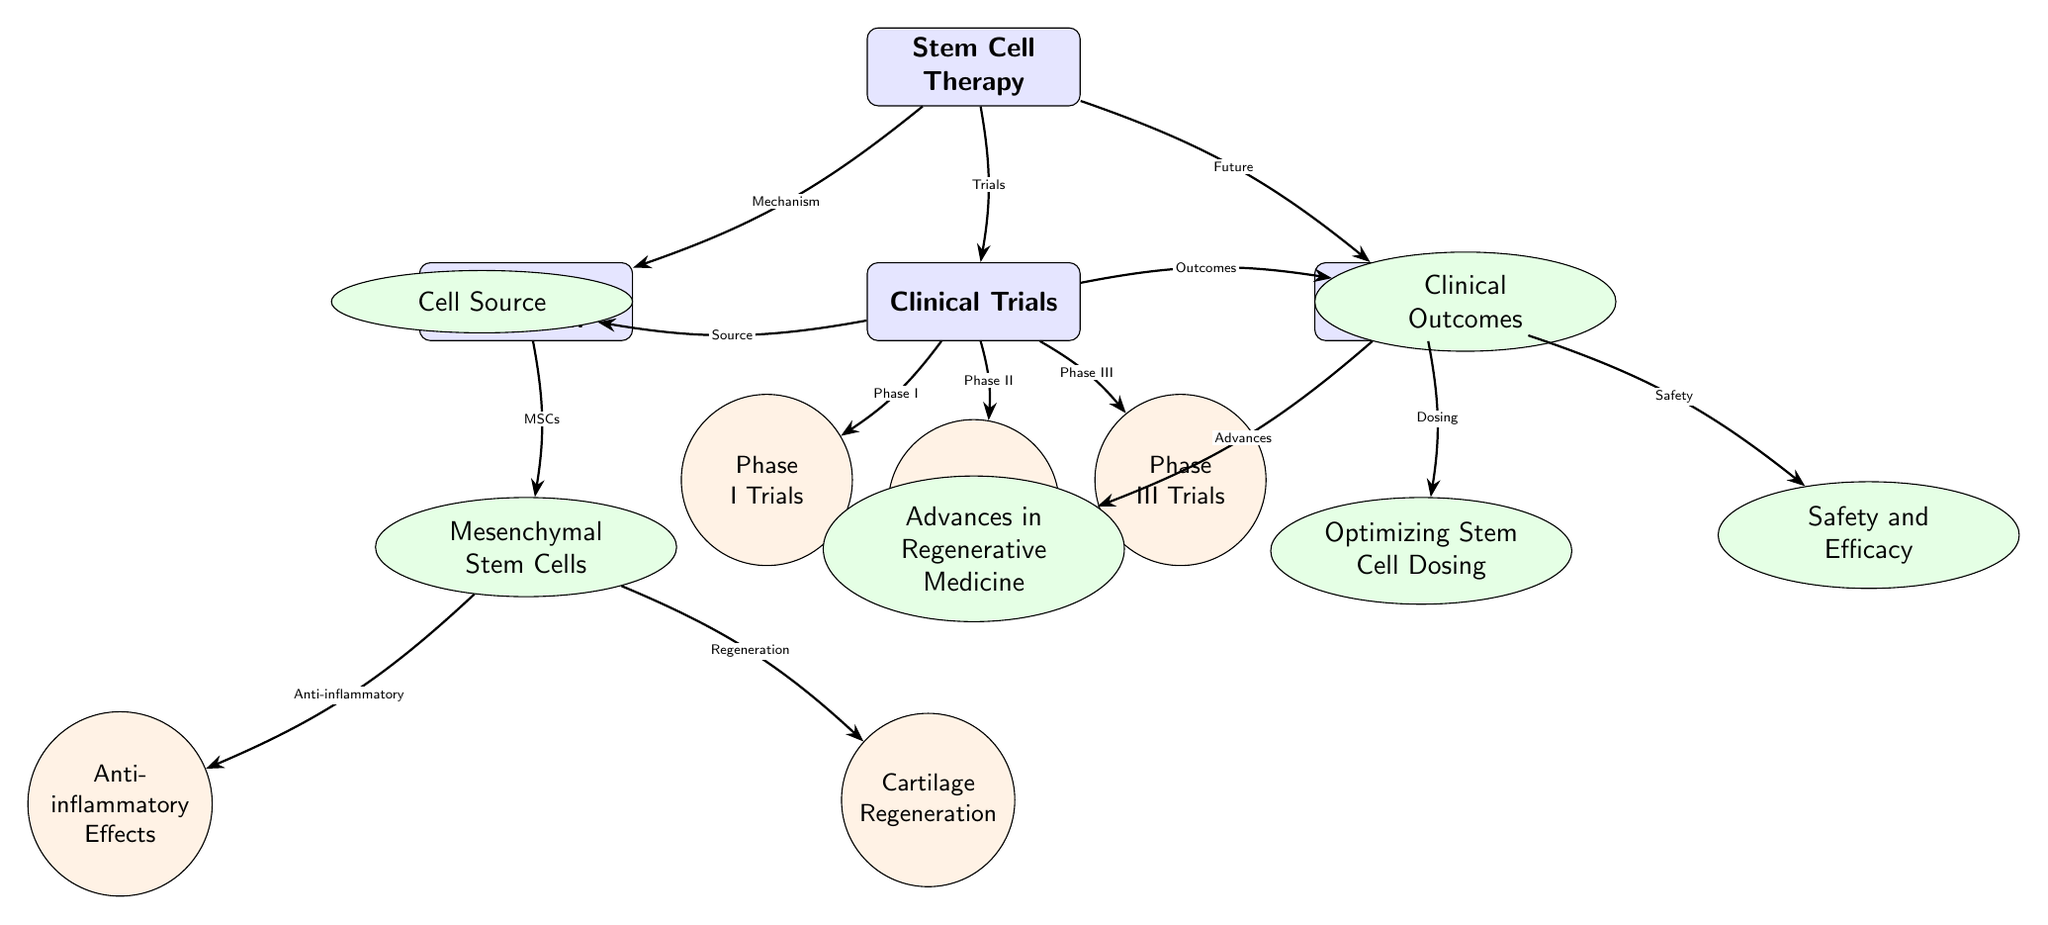What is the main focus of the diagram? The diagram primarily depicts "Stem Cell Therapy" as its central theme. It provides an overview of its mechanism of action, clinical trials, and future prospects related to osteoarthritis treatment.
Answer: Stem Cell Therapy How many main nodes are there in the diagram? There are four main nodes: Stem Cell Therapy, Mechanism of Action, Clinical Trials, and Future Prospects. Counting these nodes leads to the total number.
Answer: Four What type of stem cells is highlighted in the mechanism of action? The diagram specifies "Mesenchymal Stem Cells" as the relevant cell type in the mechanism of action related to stem cell therapy.
Answer: Mesenchymal Stem Cells Which clinical trial phase is directly connected to the "Clinical Outcomes" node? "Clinical Outcomes" has direct connections leading to the clinical trial phases, and the node that is most closely connected is specifically "Phase III Trials."
Answer: Phase III Trials What effect is associated with mesenchymal stem cells in the mechanism of action? According to the diagram, an "Anti-inflammatory" effect is attributed to mesenchymal stem cells, indicating a key role they play in the therapeutic process.
Answer: Anti-inflammatory Effects Which aspect of future prospects relates to safety? In the future prospects section of the diagram, "Safety and Efficacy" is directly connected to stem cell therapy, addressing concerns regarding treatment safety.
Answer: Safety and Efficacy What connects the primary node of stem cell therapy to clinical trials? The connection labeled "Trials" indicates the relationship between stem cell therapy and the clinical trials being conducted for it.
Answer: Trials Which node is positioned below "Cell Source" in clinical trials? "Phase I Trials" is positioned directly below "Cell Source," indicating it is one of the initial stages of clinical trials related to stem cell therapy.
Answer: Phase I Trials What are the two specific focuses under the "Mechanism of Action" node? The diagram lists "Anti-inflammatory Effects" and "Cartilage Regeneration" as the two specific focuses that detail the mechanisms through which stem cell therapy operates.
Answer: Anti-inflammatory Effects and Cartilage Regeneration 